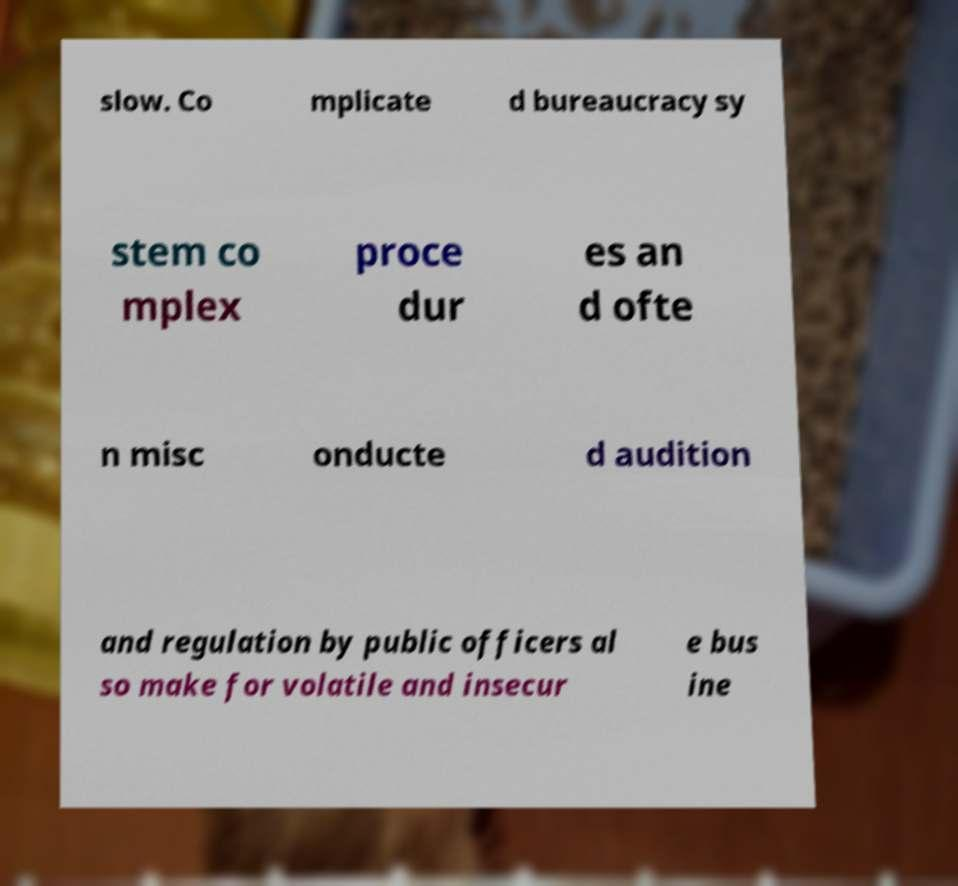For documentation purposes, I need the text within this image transcribed. Could you provide that? slow. Co mplicate d bureaucracy sy stem co mplex proce dur es an d ofte n misc onducte d audition and regulation by public officers al so make for volatile and insecur e bus ine 